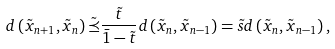<formula> <loc_0><loc_0><loc_500><loc_500>d \left ( \tilde { x } _ { n + 1 } , \tilde { x } _ { n } \right ) \tilde { \preceq } \frac { \tilde { t } } { \bar { 1 } - \tilde { t } } d \left ( \tilde { x } _ { n } , \tilde { x } _ { n - 1 } \right ) = \tilde { s } d \left ( \tilde { x } _ { n } , \tilde { x } _ { n - 1 } \right ) ,</formula> 